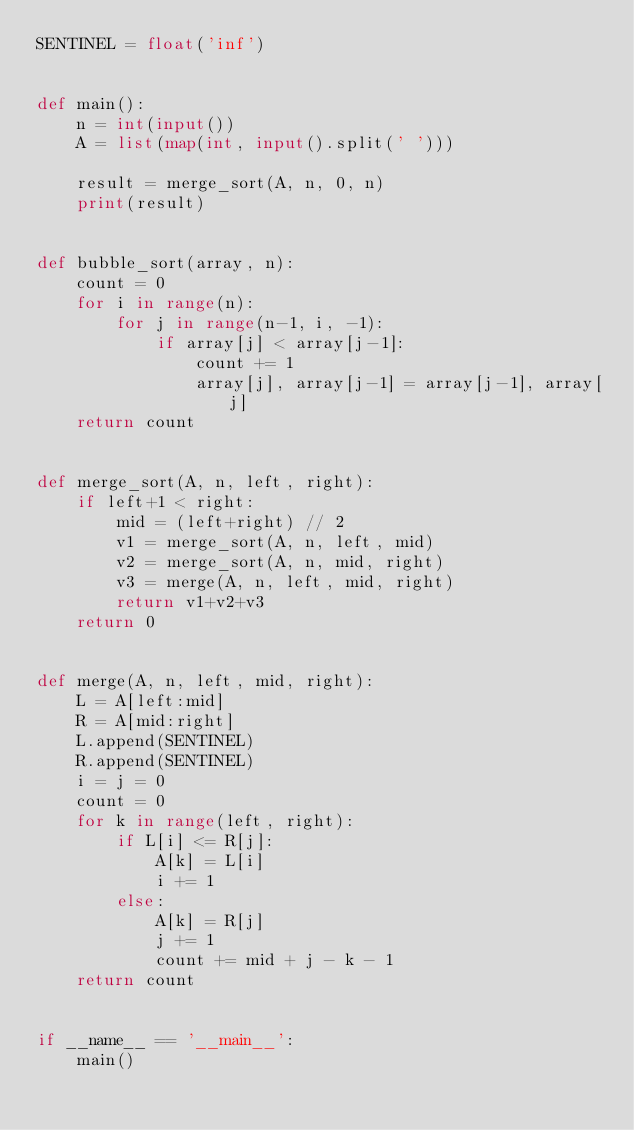<code> <loc_0><loc_0><loc_500><loc_500><_Python_>SENTINEL = float('inf')


def main():
    n = int(input())
    A = list(map(int, input().split(' ')))

    result = merge_sort(A, n, 0, n)
    print(result)


def bubble_sort(array, n):
    count = 0
    for i in range(n):
        for j in range(n-1, i, -1):
            if array[j] < array[j-1]:
                count += 1
                array[j], array[j-1] = array[j-1], array[j]
    return count


def merge_sort(A, n, left, right):
    if left+1 < right:
        mid = (left+right) // 2
        v1 = merge_sort(A, n, left, mid)
        v2 = merge_sort(A, n, mid, right)
        v3 = merge(A, n, left, mid, right)
        return v1+v2+v3
    return 0


def merge(A, n, left, mid, right):
    L = A[left:mid]
    R = A[mid:right]
    L.append(SENTINEL)
    R.append(SENTINEL)
    i = j = 0
    count = 0
    for k in range(left, right):
        if L[i] <= R[j]:
            A[k] = L[i]
            i += 1
        else:
            A[k] = R[j]
            j += 1
            count += mid + j - k - 1
    return count


if __name__ == '__main__':
    main()

</code> 